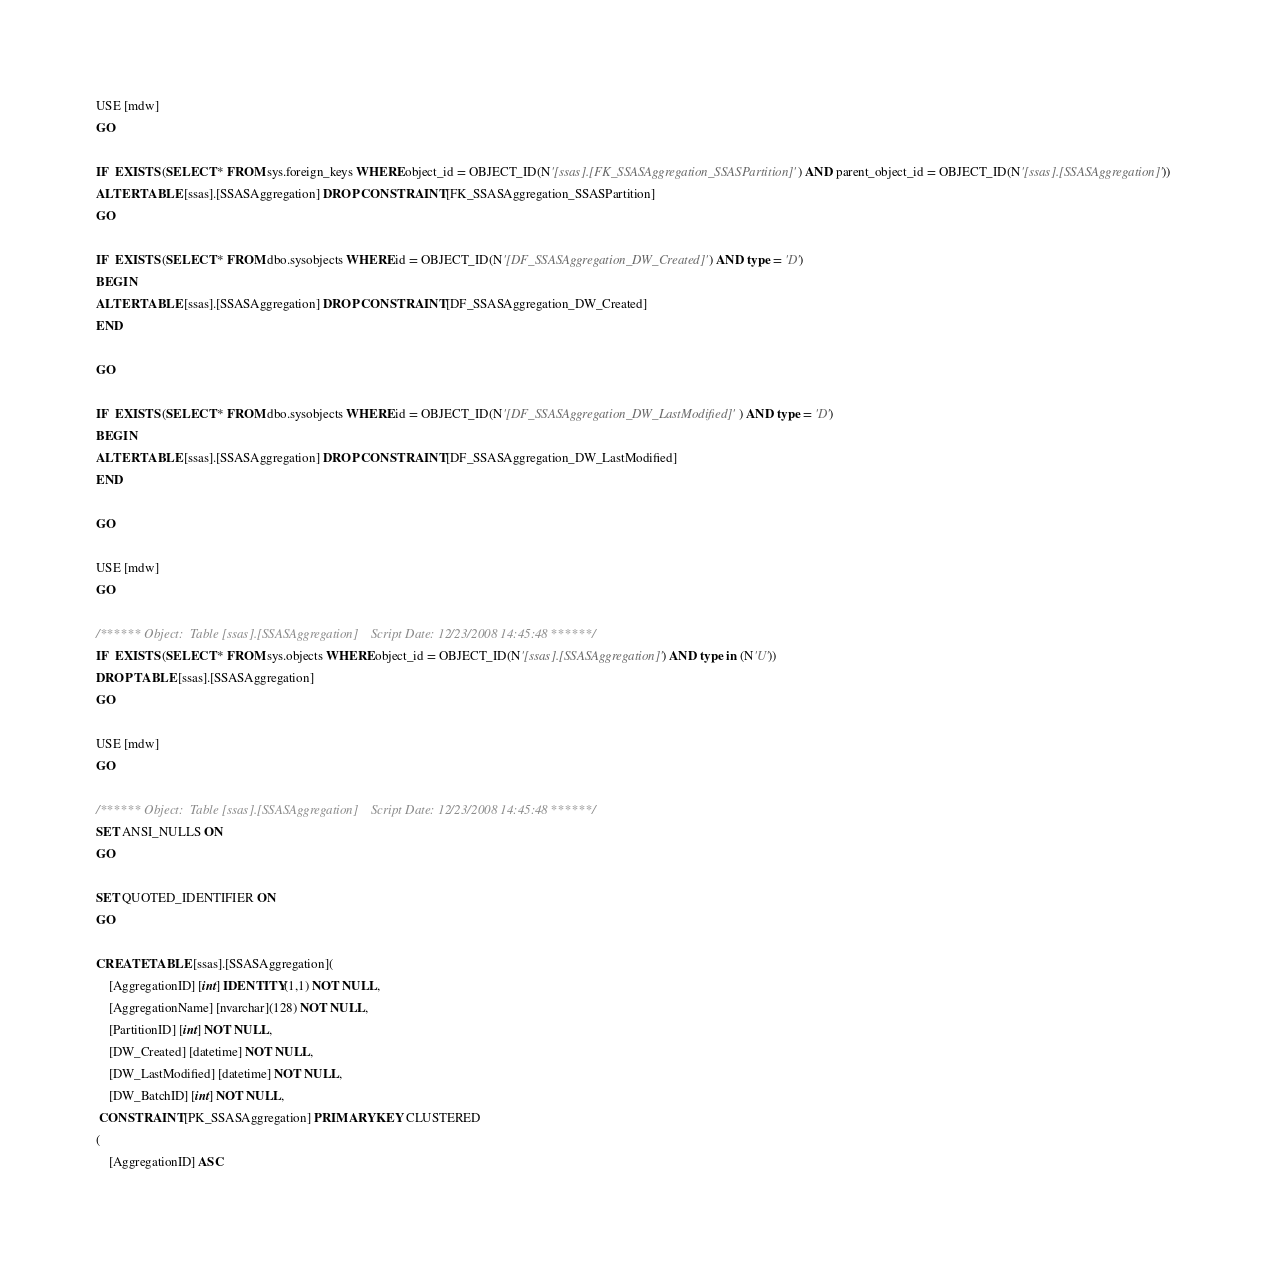<code> <loc_0><loc_0><loc_500><loc_500><_SQL_>USE [mdw]
GO

IF  EXISTS (SELECT * FROM sys.foreign_keys WHERE object_id = OBJECT_ID(N'[ssas].[FK_SSASAggregation_SSASPartition]') AND parent_object_id = OBJECT_ID(N'[ssas].[SSASAggregation]'))
ALTER TABLE [ssas].[SSASAggregation] DROP CONSTRAINT [FK_SSASAggregation_SSASPartition]
GO

IF  EXISTS (SELECT * FROM dbo.sysobjects WHERE id = OBJECT_ID(N'[DF_SSASAggregation_DW_Created]') AND type = 'D')
BEGIN
ALTER TABLE [ssas].[SSASAggregation] DROP CONSTRAINT [DF_SSASAggregation_DW_Created]
END

GO

IF  EXISTS (SELECT * FROM dbo.sysobjects WHERE id = OBJECT_ID(N'[DF_SSASAggregation_DW_LastModified]') AND type = 'D')
BEGIN
ALTER TABLE [ssas].[SSASAggregation] DROP CONSTRAINT [DF_SSASAggregation_DW_LastModified]
END

GO

USE [mdw]
GO

/****** Object:  Table [ssas].[SSASAggregation]    Script Date: 12/23/2008 14:45:48 ******/
IF  EXISTS (SELECT * FROM sys.objects WHERE object_id = OBJECT_ID(N'[ssas].[SSASAggregation]') AND type in (N'U'))
DROP TABLE [ssas].[SSASAggregation]
GO

USE [mdw]
GO

/****** Object:  Table [ssas].[SSASAggregation]    Script Date: 12/23/2008 14:45:48 ******/
SET ANSI_NULLS ON
GO

SET QUOTED_IDENTIFIER ON
GO

CREATE TABLE [ssas].[SSASAggregation](
	[AggregationID] [int] IDENTITY(1,1) NOT NULL,
	[AggregationName] [nvarchar](128) NOT NULL,
	[PartitionID] [int] NOT NULL,
	[DW_Created] [datetime] NOT NULL,
	[DW_LastModified] [datetime] NOT NULL,
	[DW_BatchID] [int] NOT NULL,
 CONSTRAINT [PK_SSASAggregation] PRIMARY KEY CLUSTERED 
(
	[AggregationID] ASC</code> 